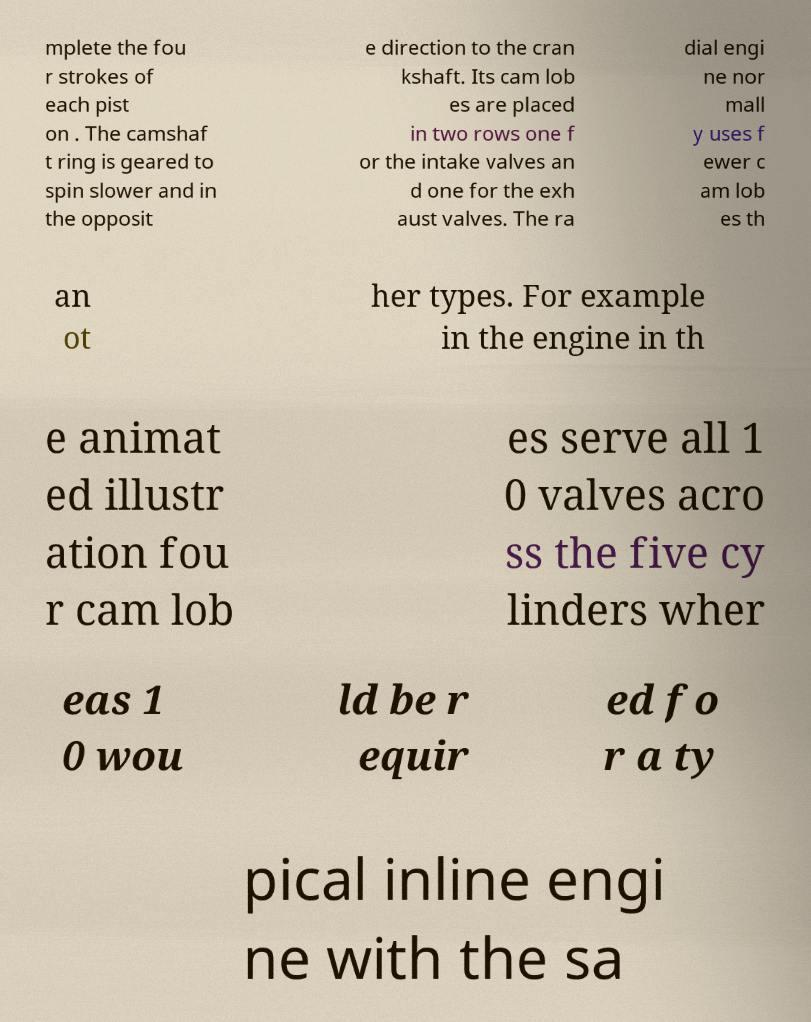Could you extract and type out the text from this image? mplete the fou r strokes of each pist on . The camshaf t ring is geared to spin slower and in the opposit e direction to the cran kshaft. Its cam lob es are placed in two rows one f or the intake valves an d one for the exh aust valves. The ra dial engi ne nor mall y uses f ewer c am lob es th an ot her types. For example in the engine in th e animat ed illustr ation fou r cam lob es serve all 1 0 valves acro ss the five cy linders wher eas 1 0 wou ld be r equir ed fo r a ty pical inline engi ne with the sa 